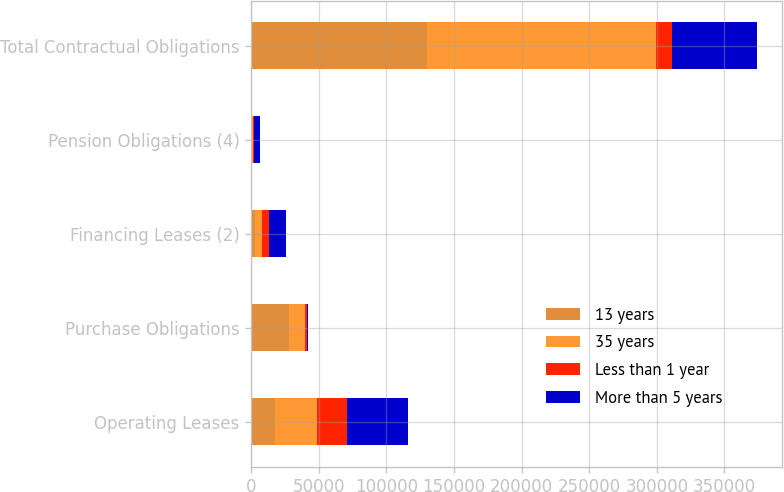Convert chart to OTSL. <chart><loc_0><loc_0><loc_500><loc_500><stacked_bar_chart><ecel><fcel>Operating Leases<fcel>Purchase Obligations<fcel>Financing Leases (2)<fcel>Pension Obligations (4)<fcel>Total Contractual Obligations<nl><fcel>13 years<fcel>17823<fcel>27940<fcel>2523<fcel>332<fcel>130367<nl><fcel>35 years<fcel>30538<fcel>11631<fcel>5148<fcel>727<fcel>168978<nl><fcel>Less than 1 year<fcel>22426<fcel>2059<fcel>5585<fcel>815<fcel>11631<nl><fcel>More than 5 years<fcel>45326<fcel>554<fcel>12282<fcel>4862<fcel>63024<nl></chart> 